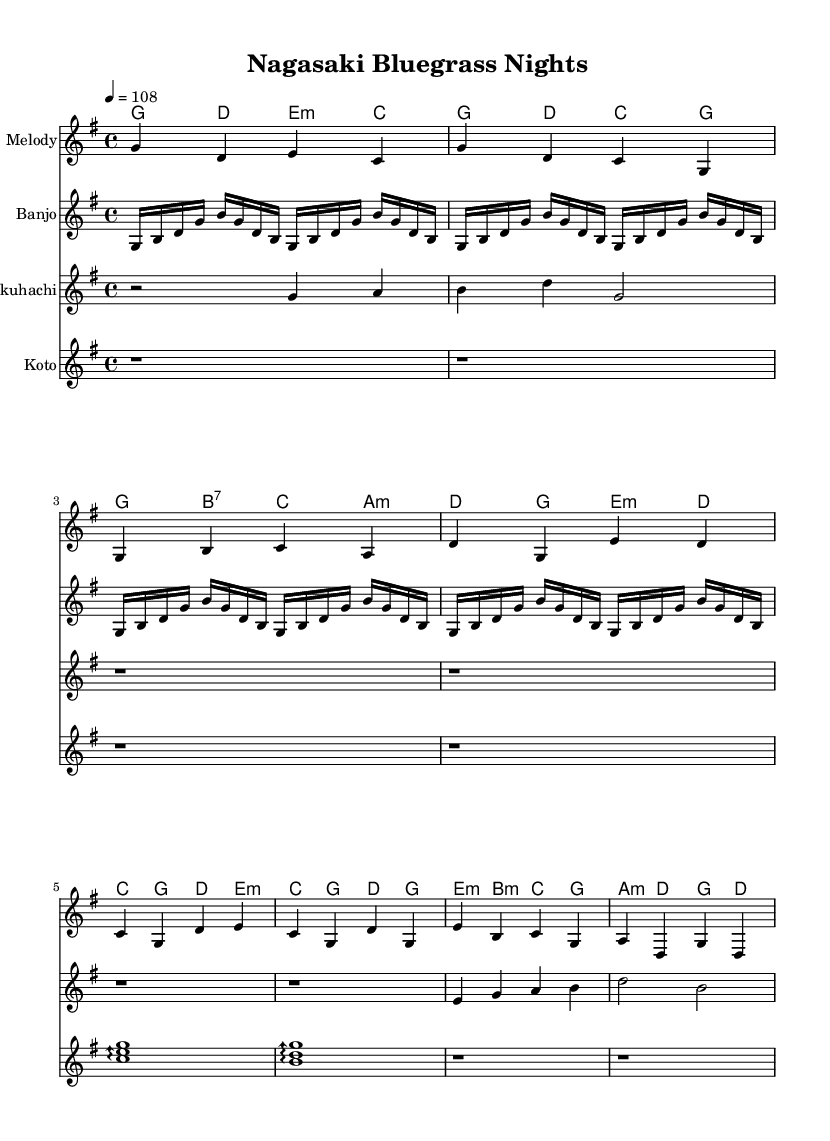What is the key signature of this music? The key signature is G major, which has one sharp (F#). This can be determined by the indication in the music typically found at the beginning of the staff.
Answer: G major What is the time signature of this music? The time signature is 4/4, which means there are four beats in each measure and the quarter note gets one beat. This is indicated by the fraction at the beginning of the score.
Answer: 4/4 What is the tempo marking of this piece? The tempo marking indicates that the music should be played at a tempo of 108 beats per minute. This is usually noted in the tempo directive written above the staff.
Answer: 108 How many measures are there in the chorus section? The chorus section consists of four measures, as indicated by counting the individual groups separated by vertical lines in the melody staff during the chorus portion of the score.
Answer: 4 Which instruments are included in this composition? The composition includes four instruments: Melody, Banjo, Shakuhachi, and Koto. This can be confirmed by looking at the different labeled staves within the score representation.
Answer: Melody, Banjo, Shakuhachi, Koto What rhythmic pattern is used for the banjo notes? The banjo notes use a simplified roll pattern that consists of eighth notes, repeated in a specific order. This can be analyzed by examining the rhythmic values represented in the banjo staff.
Answer: Eighth notes What type of melody does the shakuhachi play during the intro? The shakuhachi plays a pentatonic melody during the intro, which can be identified by the specific notes chosen that fit a five-note scale typically used in Asian music.
Answer: Pentatonic 